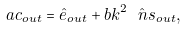<formula> <loc_0><loc_0><loc_500><loc_500>\ a c _ { o u t } = \hat { e } _ { o u t } + b k ^ { 2 } \hat { \ n s } _ { o u t } ,</formula> 